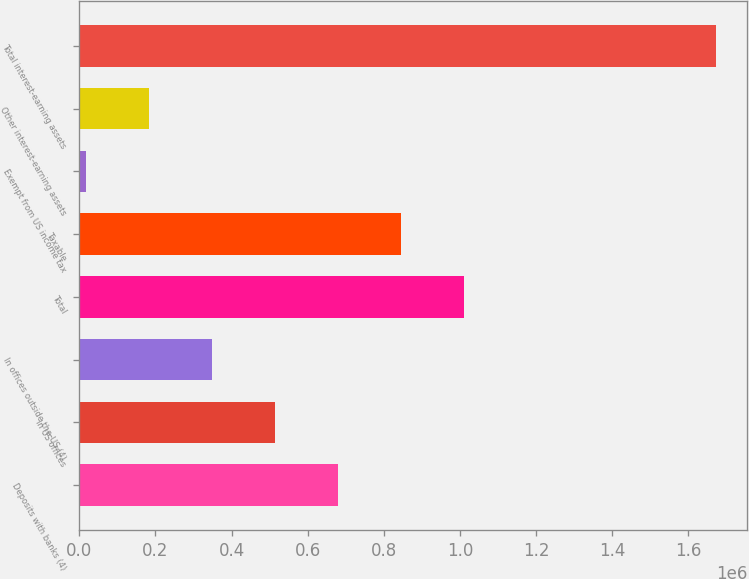Convert chart to OTSL. <chart><loc_0><loc_0><loc_500><loc_500><bar_chart><fcel>Deposits with banks (4)<fcel>In US offices<fcel>In offices outside the US (4)<fcel>Total<fcel>Taxable<fcel>Exempt from US income tax<fcel>Other interest-earning assets<fcel>Total interest-earning assets<nl><fcel>679604<fcel>514241<fcel>348878<fcel>1.01033e+06<fcel>844966<fcel>18152<fcel>183515<fcel>1.67178e+06<nl></chart> 